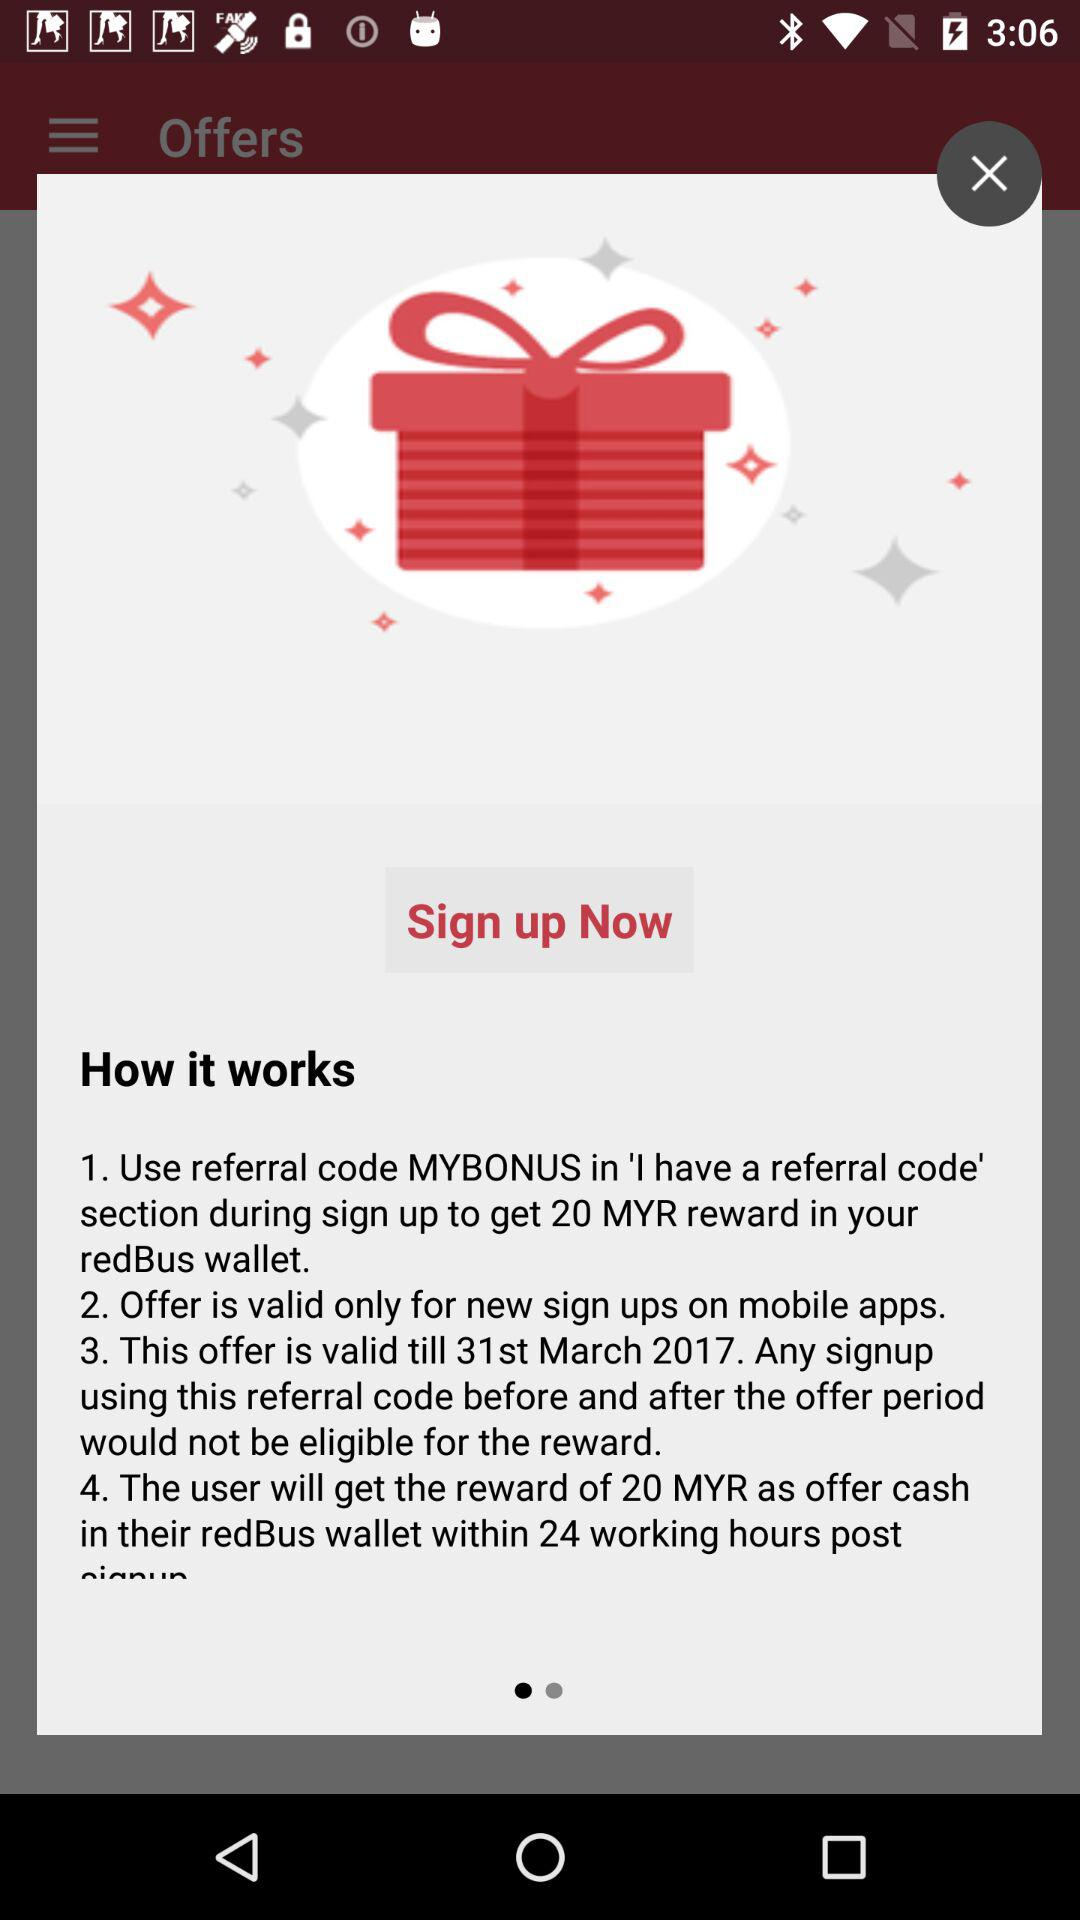How long is the offer valid? The offer is valid till March 31, 2017. 